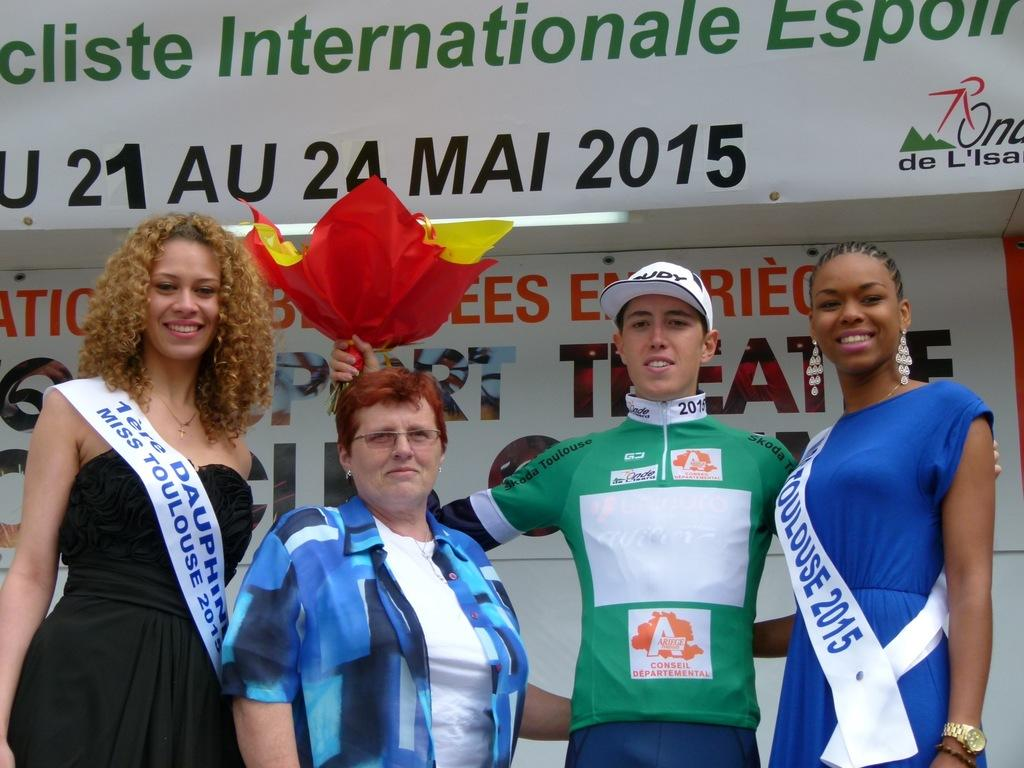<image>
Give a short and clear explanation of the subsequent image. Miss Toulouse 2015 poses with various people in front of a banner. 